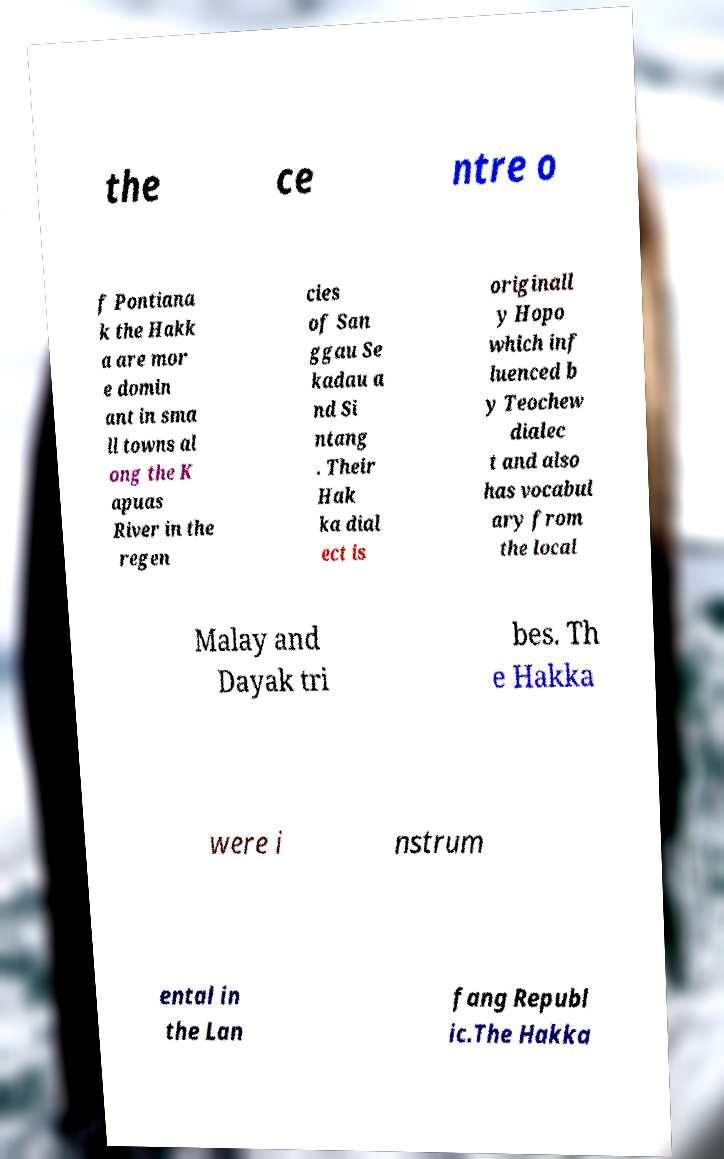Can you accurately transcribe the text from the provided image for me? the ce ntre o f Pontiana k the Hakk a are mor e domin ant in sma ll towns al ong the K apuas River in the regen cies of San ggau Se kadau a nd Si ntang . Their Hak ka dial ect is originall y Hopo which inf luenced b y Teochew dialec t and also has vocabul ary from the local Malay and Dayak tri bes. Th e Hakka were i nstrum ental in the Lan fang Republ ic.The Hakka 